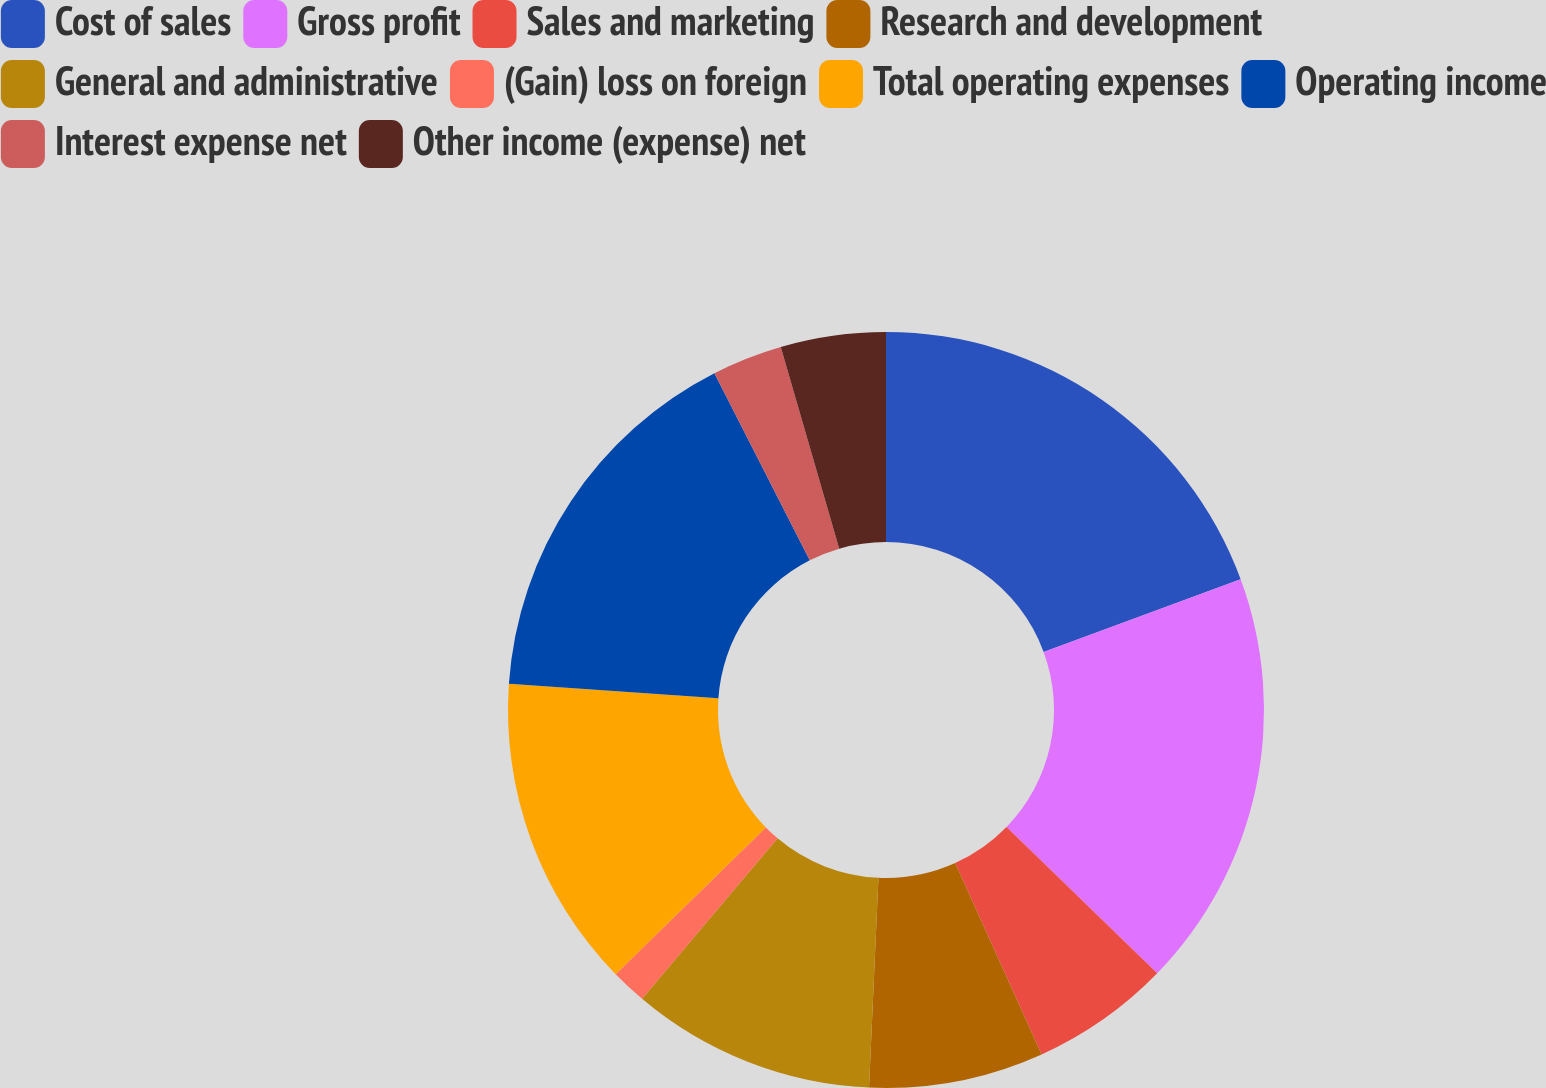Convert chart to OTSL. <chart><loc_0><loc_0><loc_500><loc_500><pie_chart><fcel>Cost of sales<fcel>Gross profit<fcel>Sales and marketing<fcel>Research and development<fcel>General and administrative<fcel>(Gain) loss on foreign<fcel>Total operating expenses<fcel>Operating income<fcel>Interest expense net<fcel>Other income (expense) net<nl><fcel>19.38%<fcel>17.89%<fcel>5.98%<fcel>7.47%<fcel>10.45%<fcel>1.52%<fcel>13.42%<fcel>16.4%<fcel>3.01%<fcel>4.49%<nl></chart> 